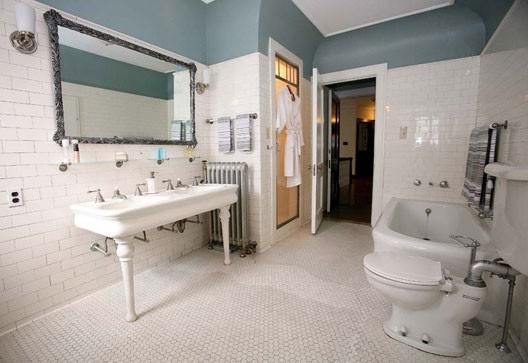Describe the objects in this image and their specific colors. I can see toilet in darkgray, gray, and lightgray tones, sink in darkgray, white, and lightgray tones, bottle in darkgray, lightgray, gray, and tan tones, and bottle in darkgray and lightgray tones in this image. 